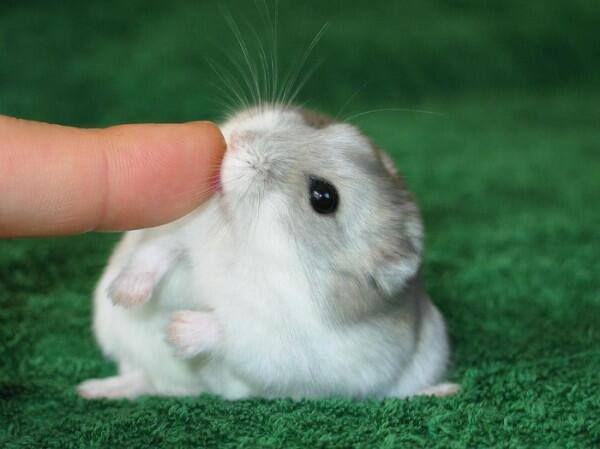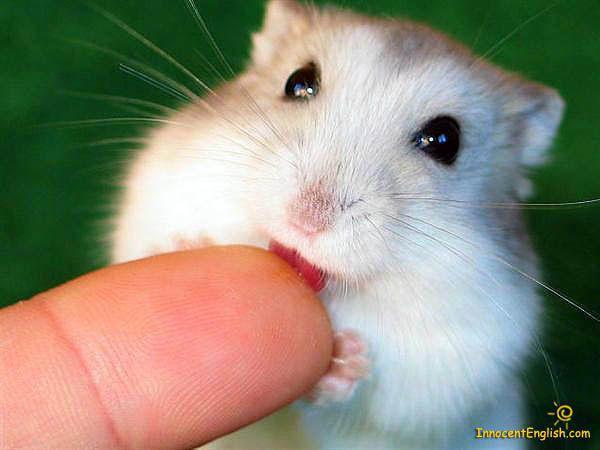The first image is the image on the left, the second image is the image on the right. For the images displayed, is the sentence "One of the images clearly shows a hamster's tongue licking someone's finger." factually correct? Answer yes or no. Yes. The first image is the image on the left, the second image is the image on the right. Examine the images to the left and right. Is the description "Has atleast one picture of an animal licking a finger" accurate? Answer yes or no. Yes. 